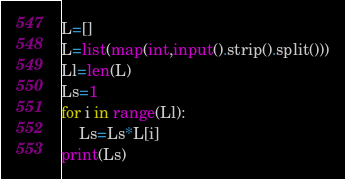Convert code to text. <code><loc_0><loc_0><loc_500><loc_500><_Python_>L=[]
L=list(map(int,input().strip().split()))
Ll=len(L)
Ls=1
for i in range(Ll):
  	Ls=Ls*L[i]
print(Ls)</code> 